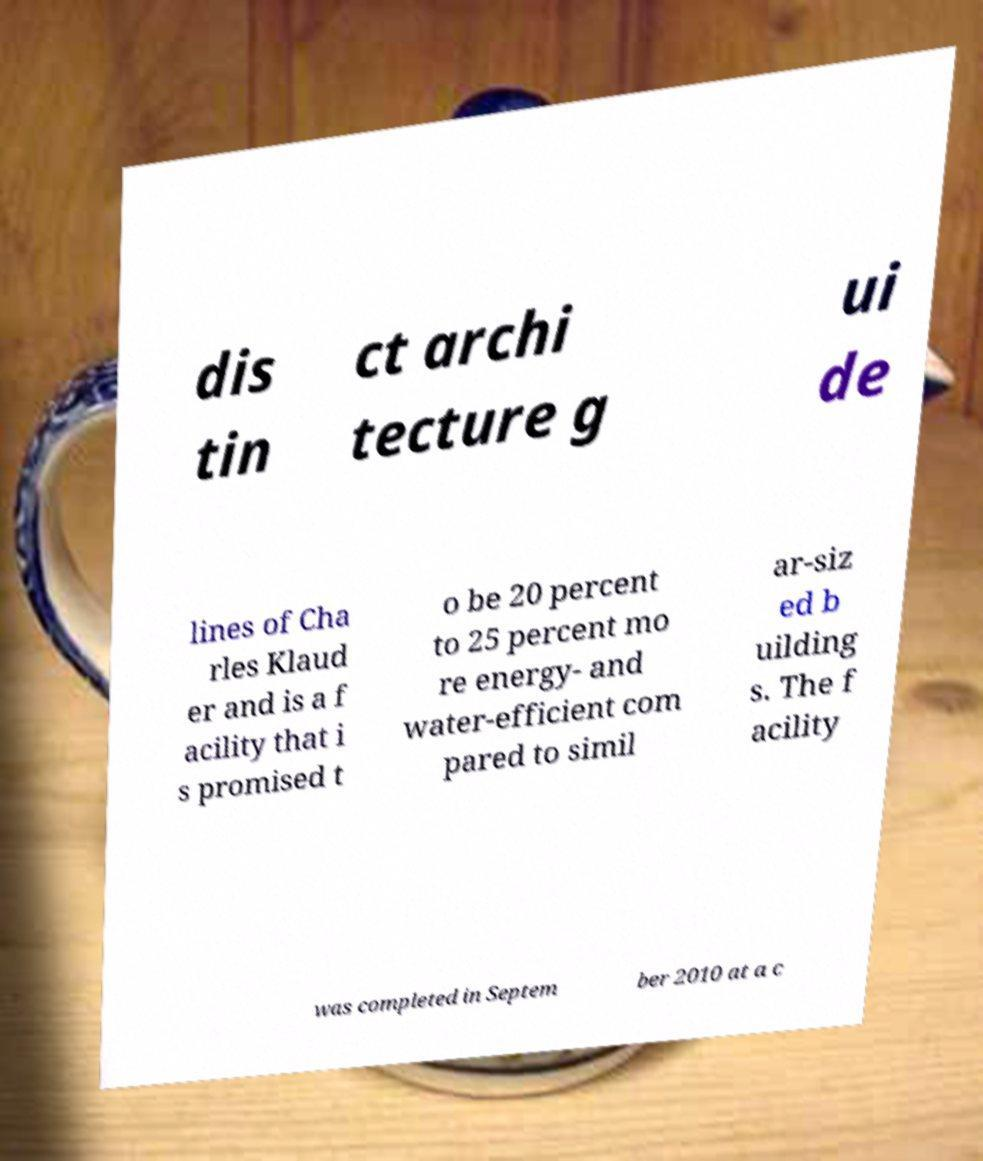Could you assist in decoding the text presented in this image and type it out clearly? dis tin ct archi tecture g ui de lines of Cha rles Klaud er and is a f acility that i s promised t o be 20 percent to 25 percent mo re energy- and water-efficient com pared to simil ar-siz ed b uilding s. The f acility was completed in Septem ber 2010 at a c 